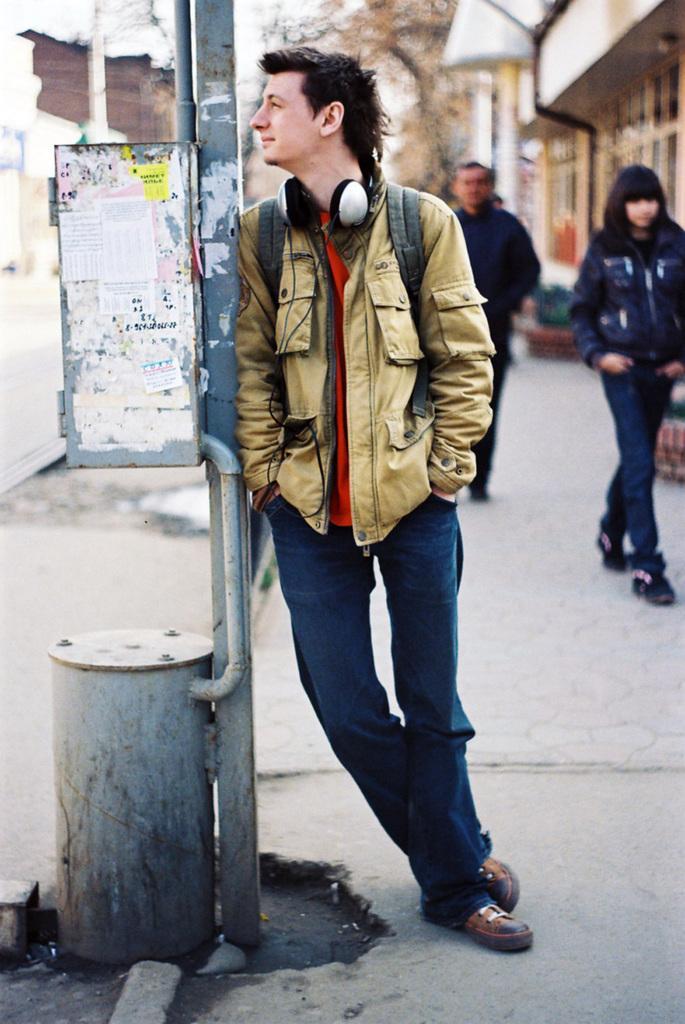Could you give a brief overview of what you see in this image? In this image in front there is a person. Beside him there is a pole and there is a metal object. Behind him there are two other people walking on the road. In the background of the image there are buildings, trees. 